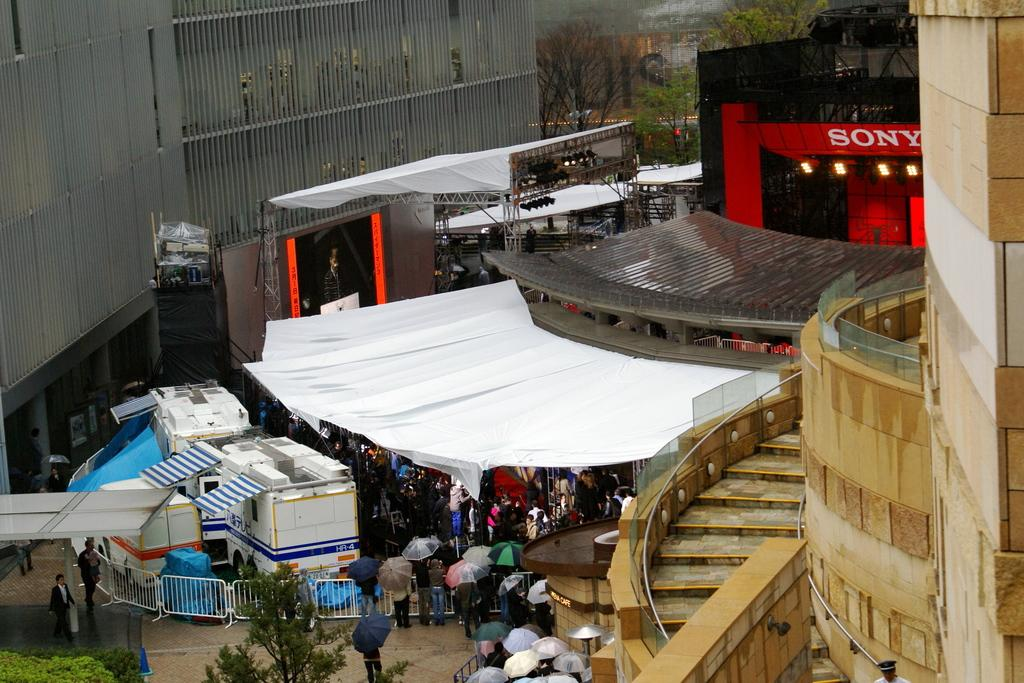What type of structures can be seen in the image? There are buildings and tents in the image. Can you describe the people in the image? There are people in the image, some of whom are holding umbrellas and others who are under the tents. What other objects or features can be seen in the image? There are trees, lights, vehicles, a fence, and plants in the image. What is the distance between the school and the love in the image? There is no mention of a school or love in the image; the facts provided only refer to buildings, tents, people, trees, lights, vehicles, a fence, and plants. 